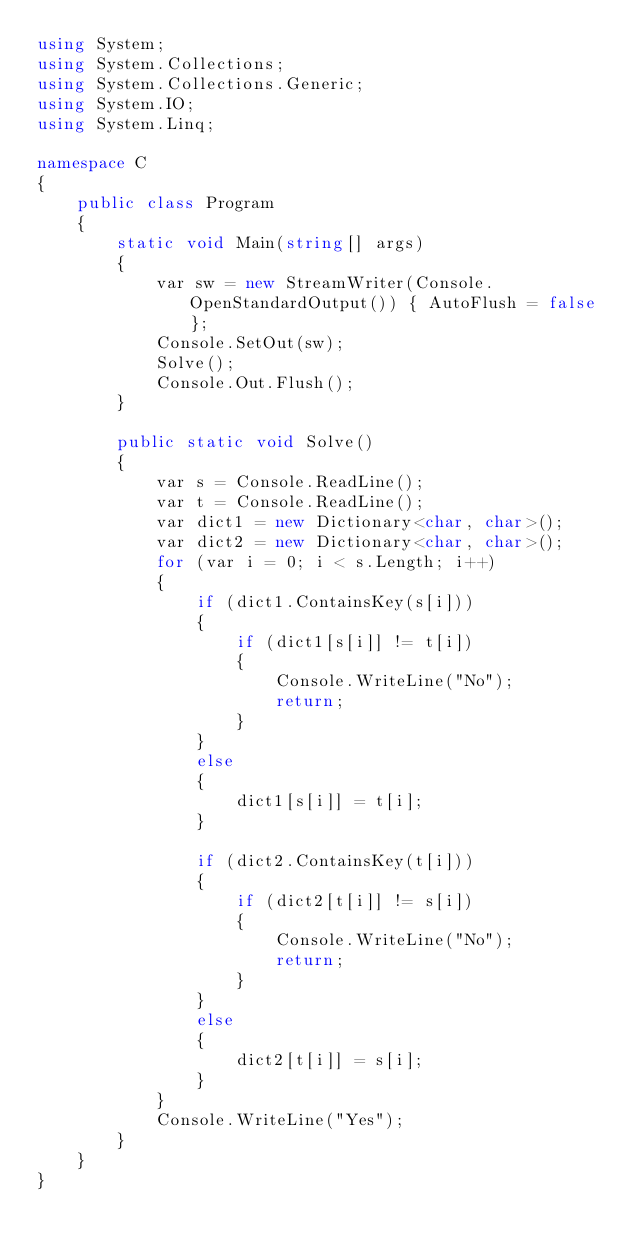<code> <loc_0><loc_0><loc_500><loc_500><_C#_>using System;
using System.Collections;
using System.Collections.Generic;
using System.IO;
using System.Linq;

namespace C
{
    public class Program
    {
        static void Main(string[] args)
        {
            var sw = new StreamWriter(Console.OpenStandardOutput()) { AutoFlush = false };
            Console.SetOut(sw);
            Solve();
            Console.Out.Flush();
        }

        public static void Solve()
        {
            var s = Console.ReadLine();
            var t = Console.ReadLine();
            var dict1 = new Dictionary<char, char>();
            var dict2 = new Dictionary<char, char>();
            for (var i = 0; i < s.Length; i++)
            {
                if (dict1.ContainsKey(s[i]))
                {
                    if (dict1[s[i]] != t[i])
                    {
                        Console.WriteLine("No");
                        return;
                    }
                }
                else
                {
                    dict1[s[i]] = t[i];
                }

                if (dict2.ContainsKey(t[i]))
                {
                    if (dict2[t[i]] != s[i])
                    {
                        Console.WriteLine("No");
                        return;
                    }
                }
                else
                {
                    dict2[t[i]] = s[i];
                }
            }
            Console.WriteLine("Yes");
        }
    }
}
</code> 